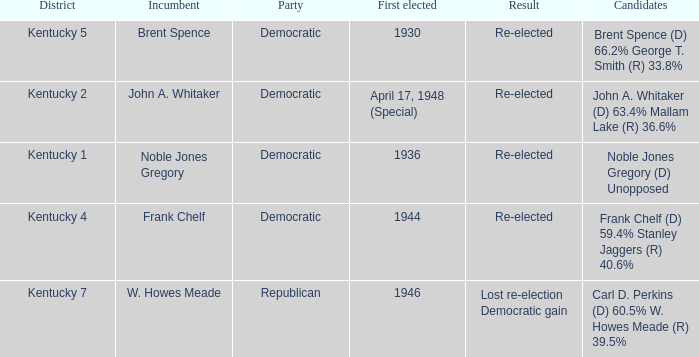Can you parse all the data within this table? {'header': ['District', 'Incumbent', 'Party', 'First elected', 'Result', 'Candidates'], 'rows': [['Kentucky 5', 'Brent Spence', 'Democratic', '1930', 'Re-elected', 'Brent Spence (D) 66.2% George T. Smith (R) 33.8%'], ['Kentucky 2', 'John A. Whitaker', 'Democratic', 'April 17, 1948 (Special)', 'Re-elected', 'John A. Whitaker (D) 63.4% Mallam Lake (R) 36.6%'], ['Kentucky 1', 'Noble Jones Gregory', 'Democratic', '1936', 'Re-elected', 'Noble Jones Gregory (D) Unopposed'], ['Kentucky 4', 'Frank Chelf', 'Democratic', '1944', 'Re-elected', 'Frank Chelf (D) 59.4% Stanley Jaggers (R) 40.6%'], ['Kentucky 7', 'W. Howes Meade', 'Republican', '1946', 'Lost re-election Democratic gain', 'Carl D. Perkins (D) 60.5% W. Howes Meade (R) 39.5%']]} Who were the candidates in the Kentucky 4 voting district? Frank Chelf (D) 59.4% Stanley Jaggers (R) 40.6%. 